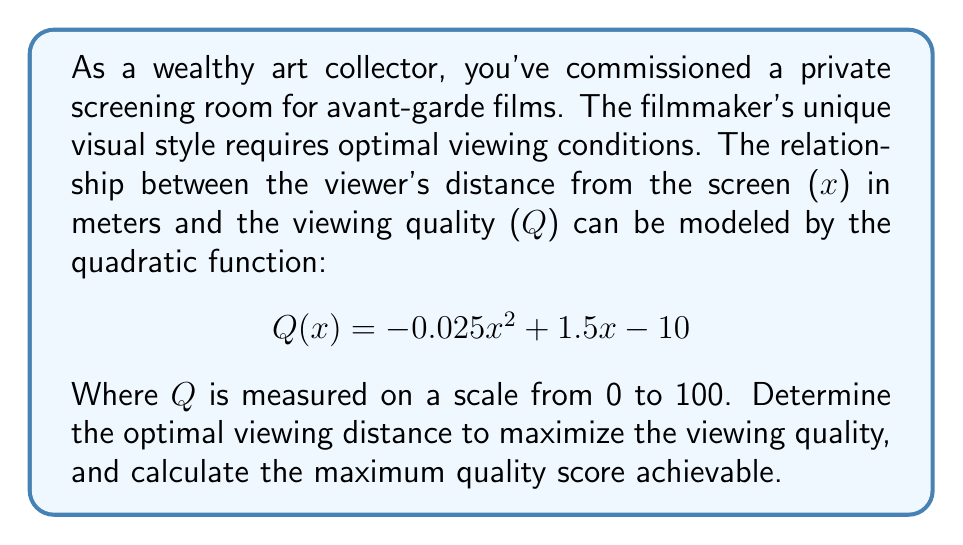Provide a solution to this math problem. To find the optimal viewing distance, we need to determine the vertex of the quadratic function, as this represents the maximum point.

1) The quadratic function is in the form $ax^2 + bx + c$, where:
   $a = -0.025$
   $b = 1.5$
   $c = -10$

2) For a quadratic function, the x-coordinate of the vertex is given by $x = -\frac{b}{2a}$

3) Substituting our values:
   $$ x = -\frac{1.5}{2(-0.025)} = -\frac{1.5}{-0.05} = 30 $$

4) Therefore, the optimal viewing distance is 30 meters.

5) To find the maximum quality score, we substitute x = 30 into our original function:

   $$ Q(30) = -0.025(30)^2 + 1.5(30) - 10 $$
   $$ = -0.025(900) + 45 - 10 $$
   $$ = -22.5 + 45 - 10 $$
   $$ = 12.5 $$

6) Therefore, the maximum quality score achievable is 12.5.

[asy]
import graph;
size(200,200);
real f(real x) {return -0.025*x^2 + 1.5*x - 10;}
draw(graph(f,0,60));
dot((30,12.5),red);
label("(30, 12.5)",(30,12.5),NE);
xaxis("x (meters)",Arrows);
yaxis("Q (quality)",Arrows);
[/asy]
Answer: The optimal viewing distance is 30 meters, and the maximum quality score achievable is 12.5. 